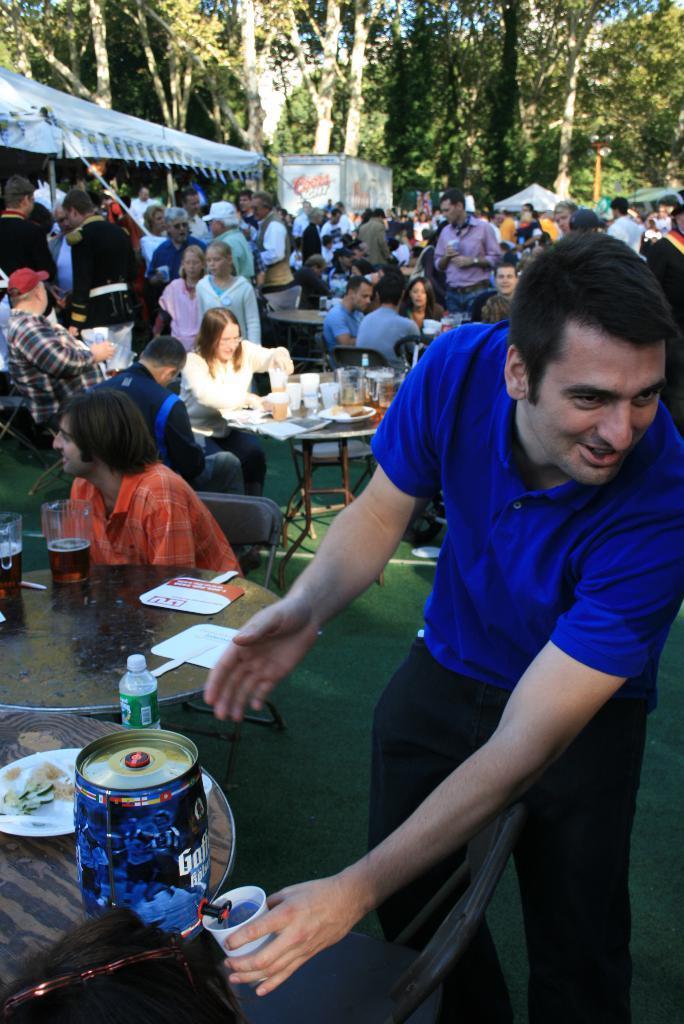In one or two sentences, can you explain what this image depicts? In this picture A man is standing and smiling on the left and the table in front of him and in the background of crowd of people and also trees 